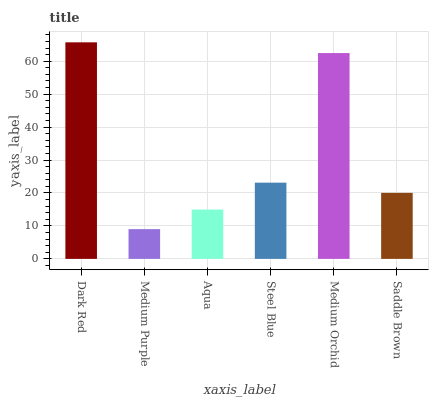Is Medium Purple the minimum?
Answer yes or no. Yes. Is Dark Red the maximum?
Answer yes or no. Yes. Is Aqua the minimum?
Answer yes or no. No. Is Aqua the maximum?
Answer yes or no. No. Is Aqua greater than Medium Purple?
Answer yes or no. Yes. Is Medium Purple less than Aqua?
Answer yes or no. Yes. Is Medium Purple greater than Aqua?
Answer yes or no. No. Is Aqua less than Medium Purple?
Answer yes or no. No. Is Steel Blue the high median?
Answer yes or no. Yes. Is Saddle Brown the low median?
Answer yes or no. Yes. Is Dark Red the high median?
Answer yes or no. No. Is Dark Red the low median?
Answer yes or no. No. 